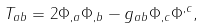Convert formula to latex. <formula><loc_0><loc_0><loc_500><loc_500>T _ { a b } = 2 \Phi _ { , a } \Phi _ { , b } - g _ { a b } \Phi _ { , c } \Phi ^ { , c } ,</formula> 